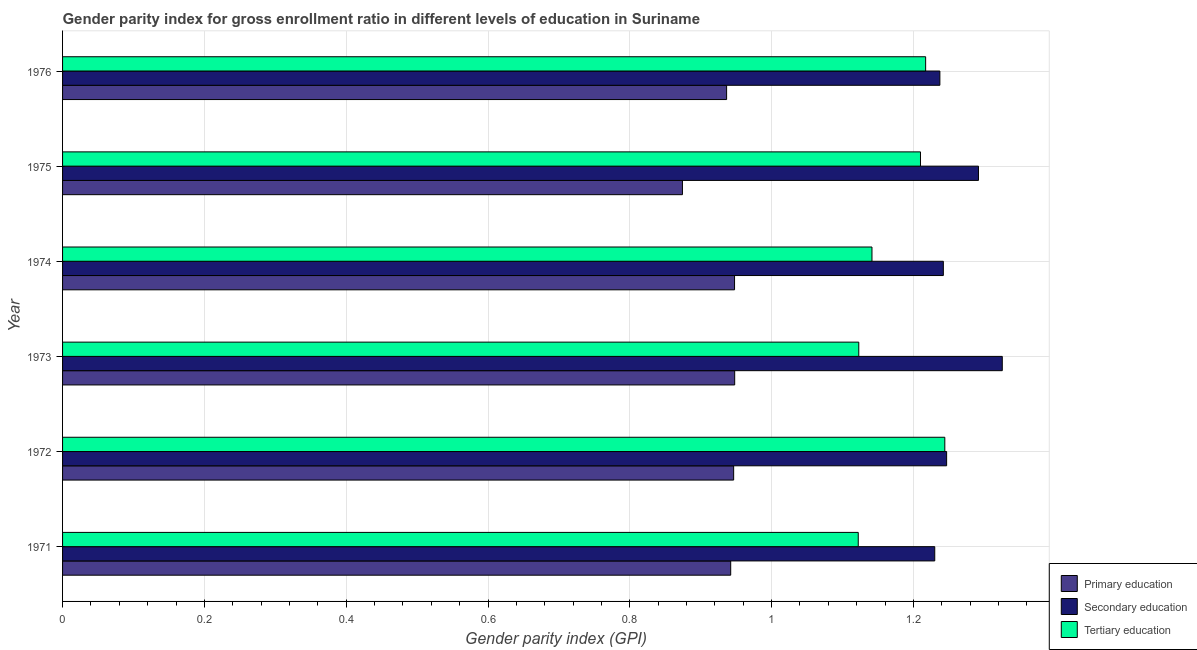How many different coloured bars are there?
Provide a short and direct response. 3. How many groups of bars are there?
Keep it short and to the point. 6. How many bars are there on the 5th tick from the top?
Your answer should be very brief. 3. In how many cases, is the number of bars for a given year not equal to the number of legend labels?
Make the answer very short. 0. What is the gender parity index in primary education in 1971?
Provide a succinct answer. 0.94. Across all years, what is the maximum gender parity index in secondary education?
Your answer should be very brief. 1.33. Across all years, what is the minimum gender parity index in primary education?
Provide a short and direct response. 0.87. In which year was the gender parity index in tertiary education maximum?
Ensure brevity in your answer.  1972. What is the total gender parity index in primary education in the graph?
Make the answer very short. 5.6. What is the difference between the gender parity index in secondary education in 1975 and that in 1976?
Your answer should be compact. 0.05. What is the difference between the gender parity index in secondary education in 1973 and the gender parity index in primary education in 1972?
Keep it short and to the point. 0.38. What is the average gender parity index in primary education per year?
Keep it short and to the point. 0.93. In the year 1976, what is the difference between the gender parity index in secondary education and gender parity index in tertiary education?
Your response must be concise. 0.02. What is the ratio of the gender parity index in primary education in 1973 to that in 1975?
Offer a terse response. 1.08. What is the difference between the highest and the lowest gender parity index in primary education?
Offer a very short reply. 0.07. In how many years, is the gender parity index in primary education greater than the average gender parity index in primary education taken over all years?
Provide a succinct answer. 5. Is the sum of the gender parity index in primary education in 1971 and 1972 greater than the maximum gender parity index in secondary education across all years?
Keep it short and to the point. Yes. What does the 2nd bar from the top in 1974 represents?
Provide a short and direct response. Secondary education. What does the 3rd bar from the bottom in 1975 represents?
Make the answer very short. Tertiary education. Is it the case that in every year, the sum of the gender parity index in primary education and gender parity index in secondary education is greater than the gender parity index in tertiary education?
Ensure brevity in your answer.  Yes. How many bars are there?
Give a very brief answer. 18. Are all the bars in the graph horizontal?
Ensure brevity in your answer.  Yes. How many years are there in the graph?
Keep it short and to the point. 6. What is the difference between two consecutive major ticks on the X-axis?
Your response must be concise. 0.2. Does the graph contain any zero values?
Your answer should be compact. No. How many legend labels are there?
Make the answer very short. 3. What is the title of the graph?
Provide a succinct answer. Gender parity index for gross enrollment ratio in different levels of education in Suriname. What is the label or title of the X-axis?
Give a very brief answer. Gender parity index (GPI). What is the Gender parity index (GPI) in Primary education in 1971?
Keep it short and to the point. 0.94. What is the Gender parity index (GPI) of Secondary education in 1971?
Give a very brief answer. 1.23. What is the Gender parity index (GPI) in Tertiary education in 1971?
Ensure brevity in your answer.  1.12. What is the Gender parity index (GPI) of Primary education in 1972?
Provide a succinct answer. 0.95. What is the Gender parity index (GPI) of Secondary education in 1972?
Your answer should be compact. 1.25. What is the Gender parity index (GPI) in Tertiary education in 1972?
Ensure brevity in your answer.  1.24. What is the Gender parity index (GPI) of Primary education in 1973?
Give a very brief answer. 0.95. What is the Gender parity index (GPI) in Secondary education in 1973?
Give a very brief answer. 1.33. What is the Gender parity index (GPI) in Tertiary education in 1973?
Offer a terse response. 1.12. What is the Gender parity index (GPI) of Primary education in 1974?
Offer a terse response. 0.95. What is the Gender parity index (GPI) of Secondary education in 1974?
Provide a succinct answer. 1.24. What is the Gender parity index (GPI) in Tertiary education in 1974?
Make the answer very short. 1.14. What is the Gender parity index (GPI) of Primary education in 1975?
Provide a short and direct response. 0.87. What is the Gender parity index (GPI) of Secondary education in 1975?
Your answer should be compact. 1.29. What is the Gender parity index (GPI) of Tertiary education in 1975?
Your response must be concise. 1.21. What is the Gender parity index (GPI) of Primary education in 1976?
Provide a succinct answer. 0.94. What is the Gender parity index (GPI) in Secondary education in 1976?
Offer a very short reply. 1.24. What is the Gender parity index (GPI) of Tertiary education in 1976?
Make the answer very short. 1.22. Across all years, what is the maximum Gender parity index (GPI) of Primary education?
Your response must be concise. 0.95. Across all years, what is the maximum Gender parity index (GPI) in Secondary education?
Your answer should be very brief. 1.33. Across all years, what is the maximum Gender parity index (GPI) of Tertiary education?
Offer a terse response. 1.24. Across all years, what is the minimum Gender parity index (GPI) of Primary education?
Provide a succinct answer. 0.87. Across all years, what is the minimum Gender parity index (GPI) in Secondary education?
Offer a terse response. 1.23. Across all years, what is the minimum Gender parity index (GPI) in Tertiary education?
Provide a succinct answer. 1.12. What is the total Gender parity index (GPI) in Primary education in the graph?
Offer a very short reply. 5.6. What is the total Gender parity index (GPI) of Secondary education in the graph?
Make the answer very short. 7.57. What is the total Gender parity index (GPI) of Tertiary education in the graph?
Provide a succinct answer. 7.06. What is the difference between the Gender parity index (GPI) of Primary education in 1971 and that in 1972?
Your answer should be compact. -0. What is the difference between the Gender parity index (GPI) of Secondary education in 1971 and that in 1972?
Your answer should be very brief. -0.02. What is the difference between the Gender parity index (GPI) of Tertiary education in 1971 and that in 1972?
Give a very brief answer. -0.12. What is the difference between the Gender parity index (GPI) in Primary education in 1971 and that in 1973?
Provide a short and direct response. -0.01. What is the difference between the Gender parity index (GPI) in Secondary education in 1971 and that in 1973?
Offer a very short reply. -0.1. What is the difference between the Gender parity index (GPI) in Tertiary education in 1971 and that in 1973?
Your response must be concise. -0. What is the difference between the Gender parity index (GPI) in Primary education in 1971 and that in 1974?
Your answer should be very brief. -0.01. What is the difference between the Gender parity index (GPI) of Secondary education in 1971 and that in 1974?
Provide a short and direct response. -0.01. What is the difference between the Gender parity index (GPI) of Tertiary education in 1971 and that in 1974?
Provide a succinct answer. -0.02. What is the difference between the Gender parity index (GPI) in Primary education in 1971 and that in 1975?
Your answer should be compact. 0.07. What is the difference between the Gender parity index (GPI) in Secondary education in 1971 and that in 1975?
Ensure brevity in your answer.  -0.06. What is the difference between the Gender parity index (GPI) of Tertiary education in 1971 and that in 1975?
Ensure brevity in your answer.  -0.09. What is the difference between the Gender parity index (GPI) in Primary education in 1971 and that in 1976?
Make the answer very short. 0.01. What is the difference between the Gender parity index (GPI) in Secondary education in 1971 and that in 1976?
Your answer should be compact. -0.01. What is the difference between the Gender parity index (GPI) of Tertiary education in 1971 and that in 1976?
Your answer should be very brief. -0.1. What is the difference between the Gender parity index (GPI) in Primary education in 1972 and that in 1973?
Your answer should be compact. -0. What is the difference between the Gender parity index (GPI) of Secondary education in 1972 and that in 1973?
Your response must be concise. -0.08. What is the difference between the Gender parity index (GPI) of Tertiary education in 1972 and that in 1973?
Your answer should be compact. 0.12. What is the difference between the Gender parity index (GPI) in Primary education in 1972 and that in 1974?
Your response must be concise. -0. What is the difference between the Gender parity index (GPI) in Secondary education in 1972 and that in 1974?
Keep it short and to the point. 0. What is the difference between the Gender parity index (GPI) in Tertiary education in 1972 and that in 1974?
Provide a short and direct response. 0.1. What is the difference between the Gender parity index (GPI) in Primary education in 1972 and that in 1975?
Keep it short and to the point. 0.07. What is the difference between the Gender parity index (GPI) in Secondary education in 1972 and that in 1975?
Your answer should be compact. -0.04. What is the difference between the Gender parity index (GPI) of Tertiary education in 1972 and that in 1975?
Your answer should be very brief. 0.03. What is the difference between the Gender parity index (GPI) of Primary education in 1972 and that in 1976?
Provide a succinct answer. 0.01. What is the difference between the Gender parity index (GPI) of Secondary education in 1972 and that in 1976?
Your answer should be very brief. 0.01. What is the difference between the Gender parity index (GPI) of Tertiary education in 1972 and that in 1976?
Provide a succinct answer. 0.03. What is the difference between the Gender parity index (GPI) of Primary education in 1973 and that in 1974?
Your answer should be very brief. 0. What is the difference between the Gender parity index (GPI) in Secondary education in 1973 and that in 1974?
Offer a terse response. 0.08. What is the difference between the Gender parity index (GPI) of Tertiary education in 1973 and that in 1974?
Offer a terse response. -0.02. What is the difference between the Gender parity index (GPI) in Primary education in 1973 and that in 1975?
Make the answer very short. 0.07. What is the difference between the Gender parity index (GPI) of Secondary education in 1973 and that in 1975?
Provide a succinct answer. 0.03. What is the difference between the Gender parity index (GPI) in Tertiary education in 1973 and that in 1975?
Provide a succinct answer. -0.09. What is the difference between the Gender parity index (GPI) in Primary education in 1973 and that in 1976?
Offer a very short reply. 0.01. What is the difference between the Gender parity index (GPI) in Secondary education in 1973 and that in 1976?
Offer a terse response. 0.09. What is the difference between the Gender parity index (GPI) of Tertiary education in 1973 and that in 1976?
Ensure brevity in your answer.  -0.09. What is the difference between the Gender parity index (GPI) in Primary education in 1974 and that in 1975?
Your response must be concise. 0.07. What is the difference between the Gender parity index (GPI) of Secondary education in 1974 and that in 1975?
Your answer should be very brief. -0.05. What is the difference between the Gender parity index (GPI) in Tertiary education in 1974 and that in 1975?
Ensure brevity in your answer.  -0.07. What is the difference between the Gender parity index (GPI) in Primary education in 1974 and that in 1976?
Ensure brevity in your answer.  0.01. What is the difference between the Gender parity index (GPI) in Secondary education in 1974 and that in 1976?
Your answer should be compact. 0. What is the difference between the Gender parity index (GPI) in Tertiary education in 1974 and that in 1976?
Make the answer very short. -0.08. What is the difference between the Gender parity index (GPI) of Primary education in 1975 and that in 1976?
Your response must be concise. -0.06. What is the difference between the Gender parity index (GPI) in Secondary education in 1975 and that in 1976?
Offer a very short reply. 0.05. What is the difference between the Gender parity index (GPI) of Tertiary education in 1975 and that in 1976?
Offer a very short reply. -0.01. What is the difference between the Gender parity index (GPI) in Primary education in 1971 and the Gender parity index (GPI) in Secondary education in 1972?
Your response must be concise. -0.3. What is the difference between the Gender parity index (GPI) in Primary education in 1971 and the Gender parity index (GPI) in Tertiary education in 1972?
Make the answer very short. -0.3. What is the difference between the Gender parity index (GPI) in Secondary education in 1971 and the Gender parity index (GPI) in Tertiary education in 1972?
Your answer should be compact. -0.01. What is the difference between the Gender parity index (GPI) in Primary education in 1971 and the Gender parity index (GPI) in Secondary education in 1973?
Offer a terse response. -0.38. What is the difference between the Gender parity index (GPI) of Primary education in 1971 and the Gender parity index (GPI) of Tertiary education in 1973?
Your answer should be compact. -0.18. What is the difference between the Gender parity index (GPI) of Secondary education in 1971 and the Gender parity index (GPI) of Tertiary education in 1973?
Make the answer very short. 0.11. What is the difference between the Gender parity index (GPI) of Primary education in 1971 and the Gender parity index (GPI) of Secondary education in 1974?
Provide a short and direct response. -0.3. What is the difference between the Gender parity index (GPI) of Primary education in 1971 and the Gender parity index (GPI) of Tertiary education in 1974?
Your answer should be compact. -0.2. What is the difference between the Gender parity index (GPI) of Secondary education in 1971 and the Gender parity index (GPI) of Tertiary education in 1974?
Ensure brevity in your answer.  0.09. What is the difference between the Gender parity index (GPI) of Primary education in 1971 and the Gender parity index (GPI) of Secondary education in 1975?
Provide a short and direct response. -0.35. What is the difference between the Gender parity index (GPI) in Primary education in 1971 and the Gender parity index (GPI) in Tertiary education in 1975?
Keep it short and to the point. -0.27. What is the difference between the Gender parity index (GPI) of Secondary education in 1971 and the Gender parity index (GPI) of Tertiary education in 1975?
Your answer should be compact. 0.02. What is the difference between the Gender parity index (GPI) of Primary education in 1971 and the Gender parity index (GPI) of Secondary education in 1976?
Your answer should be compact. -0.29. What is the difference between the Gender parity index (GPI) in Primary education in 1971 and the Gender parity index (GPI) in Tertiary education in 1976?
Provide a short and direct response. -0.27. What is the difference between the Gender parity index (GPI) of Secondary education in 1971 and the Gender parity index (GPI) of Tertiary education in 1976?
Keep it short and to the point. 0.01. What is the difference between the Gender parity index (GPI) in Primary education in 1972 and the Gender parity index (GPI) in Secondary education in 1973?
Your response must be concise. -0.38. What is the difference between the Gender parity index (GPI) in Primary education in 1972 and the Gender parity index (GPI) in Tertiary education in 1973?
Provide a short and direct response. -0.18. What is the difference between the Gender parity index (GPI) of Secondary education in 1972 and the Gender parity index (GPI) of Tertiary education in 1973?
Offer a terse response. 0.12. What is the difference between the Gender parity index (GPI) of Primary education in 1972 and the Gender parity index (GPI) of Secondary education in 1974?
Give a very brief answer. -0.3. What is the difference between the Gender parity index (GPI) of Primary education in 1972 and the Gender parity index (GPI) of Tertiary education in 1974?
Your answer should be compact. -0.2. What is the difference between the Gender parity index (GPI) in Secondary education in 1972 and the Gender parity index (GPI) in Tertiary education in 1974?
Offer a very short reply. 0.11. What is the difference between the Gender parity index (GPI) in Primary education in 1972 and the Gender parity index (GPI) in Secondary education in 1975?
Offer a terse response. -0.35. What is the difference between the Gender parity index (GPI) of Primary education in 1972 and the Gender parity index (GPI) of Tertiary education in 1975?
Give a very brief answer. -0.26. What is the difference between the Gender parity index (GPI) in Secondary education in 1972 and the Gender parity index (GPI) in Tertiary education in 1975?
Offer a terse response. 0.04. What is the difference between the Gender parity index (GPI) in Primary education in 1972 and the Gender parity index (GPI) in Secondary education in 1976?
Your response must be concise. -0.29. What is the difference between the Gender parity index (GPI) of Primary education in 1972 and the Gender parity index (GPI) of Tertiary education in 1976?
Provide a succinct answer. -0.27. What is the difference between the Gender parity index (GPI) in Secondary education in 1972 and the Gender parity index (GPI) in Tertiary education in 1976?
Make the answer very short. 0.03. What is the difference between the Gender parity index (GPI) of Primary education in 1973 and the Gender parity index (GPI) of Secondary education in 1974?
Provide a short and direct response. -0.29. What is the difference between the Gender parity index (GPI) in Primary education in 1973 and the Gender parity index (GPI) in Tertiary education in 1974?
Offer a terse response. -0.19. What is the difference between the Gender parity index (GPI) of Secondary education in 1973 and the Gender parity index (GPI) of Tertiary education in 1974?
Make the answer very short. 0.18. What is the difference between the Gender parity index (GPI) in Primary education in 1973 and the Gender parity index (GPI) in Secondary education in 1975?
Provide a short and direct response. -0.34. What is the difference between the Gender parity index (GPI) of Primary education in 1973 and the Gender parity index (GPI) of Tertiary education in 1975?
Give a very brief answer. -0.26. What is the difference between the Gender parity index (GPI) in Secondary education in 1973 and the Gender parity index (GPI) in Tertiary education in 1975?
Provide a succinct answer. 0.12. What is the difference between the Gender parity index (GPI) in Primary education in 1973 and the Gender parity index (GPI) in Secondary education in 1976?
Your response must be concise. -0.29. What is the difference between the Gender parity index (GPI) in Primary education in 1973 and the Gender parity index (GPI) in Tertiary education in 1976?
Give a very brief answer. -0.27. What is the difference between the Gender parity index (GPI) of Secondary education in 1973 and the Gender parity index (GPI) of Tertiary education in 1976?
Offer a terse response. 0.11. What is the difference between the Gender parity index (GPI) in Primary education in 1974 and the Gender parity index (GPI) in Secondary education in 1975?
Provide a succinct answer. -0.34. What is the difference between the Gender parity index (GPI) of Primary education in 1974 and the Gender parity index (GPI) of Tertiary education in 1975?
Offer a terse response. -0.26. What is the difference between the Gender parity index (GPI) in Secondary education in 1974 and the Gender parity index (GPI) in Tertiary education in 1975?
Ensure brevity in your answer.  0.03. What is the difference between the Gender parity index (GPI) of Primary education in 1974 and the Gender parity index (GPI) of Secondary education in 1976?
Offer a terse response. -0.29. What is the difference between the Gender parity index (GPI) of Primary education in 1974 and the Gender parity index (GPI) of Tertiary education in 1976?
Your response must be concise. -0.27. What is the difference between the Gender parity index (GPI) of Secondary education in 1974 and the Gender parity index (GPI) of Tertiary education in 1976?
Provide a succinct answer. 0.03. What is the difference between the Gender parity index (GPI) in Primary education in 1975 and the Gender parity index (GPI) in Secondary education in 1976?
Provide a succinct answer. -0.36. What is the difference between the Gender parity index (GPI) in Primary education in 1975 and the Gender parity index (GPI) in Tertiary education in 1976?
Your response must be concise. -0.34. What is the difference between the Gender parity index (GPI) of Secondary education in 1975 and the Gender parity index (GPI) of Tertiary education in 1976?
Provide a succinct answer. 0.07. What is the average Gender parity index (GPI) of Primary education per year?
Give a very brief answer. 0.93. What is the average Gender parity index (GPI) in Secondary education per year?
Ensure brevity in your answer.  1.26. What is the average Gender parity index (GPI) in Tertiary education per year?
Your response must be concise. 1.18. In the year 1971, what is the difference between the Gender parity index (GPI) of Primary education and Gender parity index (GPI) of Secondary education?
Give a very brief answer. -0.29. In the year 1971, what is the difference between the Gender parity index (GPI) in Primary education and Gender parity index (GPI) in Tertiary education?
Give a very brief answer. -0.18. In the year 1971, what is the difference between the Gender parity index (GPI) in Secondary education and Gender parity index (GPI) in Tertiary education?
Your answer should be very brief. 0.11. In the year 1972, what is the difference between the Gender parity index (GPI) in Primary education and Gender parity index (GPI) in Secondary education?
Offer a very short reply. -0.3. In the year 1972, what is the difference between the Gender parity index (GPI) of Primary education and Gender parity index (GPI) of Tertiary education?
Your response must be concise. -0.3. In the year 1972, what is the difference between the Gender parity index (GPI) of Secondary education and Gender parity index (GPI) of Tertiary education?
Keep it short and to the point. 0. In the year 1973, what is the difference between the Gender parity index (GPI) in Primary education and Gender parity index (GPI) in Secondary education?
Offer a very short reply. -0.38. In the year 1973, what is the difference between the Gender parity index (GPI) of Primary education and Gender parity index (GPI) of Tertiary education?
Ensure brevity in your answer.  -0.17. In the year 1973, what is the difference between the Gender parity index (GPI) of Secondary education and Gender parity index (GPI) of Tertiary education?
Provide a short and direct response. 0.2. In the year 1974, what is the difference between the Gender parity index (GPI) of Primary education and Gender parity index (GPI) of Secondary education?
Your answer should be very brief. -0.29. In the year 1974, what is the difference between the Gender parity index (GPI) of Primary education and Gender parity index (GPI) of Tertiary education?
Give a very brief answer. -0.19. In the year 1974, what is the difference between the Gender parity index (GPI) of Secondary education and Gender parity index (GPI) of Tertiary education?
Your answer should be very brief. 0.1. In the year 1975, what is the difference between the Gender parity index (GPI) of Primary education and Gender parity index (GPI) of Secondary education?
Provide a short and direct response. -0.42. In the year 1975, what is the difference between the Gender parity index (GPI) in Primary education and Gender parity index (GPI) in Tertiary education?
Your answer should be very brief. -0.34. In the year 1975, what is the difference between the Gender parity index (GPI) of Secondary education and Gender parity index (GPI) of Tertiary education?
Your answer should be compact. 0.08. In the year 1976, what is the difference between the Gender parity index (GPI) of Primary education and Gender parity index (GPI) of Secondary education?
Keep it short and to the point. -0.3. In the year 1976, what is the difference between the Gender parity index (GPI) in Primary education and Gender parity index (GPI) in Tertiary education?
Make the answer very short. -0.28. In the year 1976, what is the difference between the Gender parity index (GPI) in Secondary education and Gender parity index (GPI) in Tertiary education?
Your response must be concise. 0.02. What is the ratio of the Gender parity index (GPI) of Secondary education in 1971 to that in 1972?
Provide a succinct answer. 0.99. What is the ratio of the Gender parity index (GPI) in Tertiary education in 1971 to that in 1972?
Offer a very short reply. 0.9. What is the ratio of the Gender parity index (GPI) in Primary education in 1971 to that in 1973?
Your response must be concise. 0.99. What is the ratio of the Gender parity index (GPI) in Secondary education in 1971 to that in 1973?
Give a very brief answer. 0.93. What is the ratio of the Gender parity index (GPI) in Primary education in 1971 to that in 1974?
Provide a succinct answer. 0.99. What is the ratio of the Gender parity index (GPI) in Secondary education in 1971 to that in 1974?
Your response must be concise. 0.99. What is the ratio of the Gender parity index (GPI) in Tertiary education in 1971 to that in 1974?
Provide a short and direct response. 0.98. What is the ratio of the Gender parity index (GPI) in Primary education in 1971 to that in 1975?
Give a very brief answer. 1.08. What is the ratio of the Gender parity index (GPI) of Secondary education in 1971 to that in 1975?
Give a very brief answer. 0.95. What is the ratio of the Gender parity index (GPI) in Tertiary education in 1971 to that in 1975?
Your answer should be very brief. 0.93. What is the ratio of the Gender parity index (GPI) in Secondary education in 1971 to that in 1976?
Ensure brevity in your answer.  0.99. What is the ratio of the Gender parity index (GPI) of Tertiary education in 1971 to that in 1976?
Ensure brevity in your answer.  0.92. What is the ratio of the Gender parity index (GPI) in Secondary education in 1972 to that in 1973?
Your answer should be compact. 0.94. What is the ratio of the Gender parity index (GPI) in Tertiary education in 1972 to that in 1973?
Make the answer very short. 1.11. What is the ratio of the Gender parity index (GPI) of Primary education in 1972 to that in 1974?
Your answer should be very brief. 1. What is the ratio of the Gender parity index (GPI) in Secondary education in 1972 to that in 1974?
Provide a short and direct response. 1. What is the ratio of the Gender parity index (GPI) in Tertiary education in 1972 to that in 1974?
Provide a short and direct response. 1.09. What is the ratio of the Gender parity index (GPI) of Primary education in 1972 to that in 1975?
Your answer should be very brief. 1.08. What is the ratio of the Gender parity index (GPI) of Secondary education in 1972 to that in 1975?
Make the answer very short. 0.97. What is the ratio of the Gender parity index (GPI) of Tertiary education in 1972 to that in 1975?
Ensure brevity in your answer.  1.03. What is the ratio of the Gender parity index (GPI) in Primary education in 1972 to that in 1976?
Your answer should be very brief. 1.01. What is the ratio of the Gender parity index (GPI) in Secondary education in 1972 to that in 1976?
Offer a very short reply. 1.01. What is the ratio of the Gender parity index (GPI) in Tertiary education in 1972 to that in 1976?
Make the answer very short. 1.02. What is the ratio of the Gender parity index (GPI) of Primary education in 1973 to that in 1974?
Offer a very short reply. 1. What is the ratio of the Gender parity index (GPI) of Secondary education in 1973 to that in 1974?
Give a very brief answer. 1.07. What is the ratio of the Gender parity index (GPI) in Tertiary education in 1973 to that in 1974?
Offer a very short reply. 0.98. What is the ratio of the Gender parity index (GPI) of Primary education in 1973 to that in 1975?
Ensure brevity in your answer.  1.08. What is the ratio of the Gender parity index (GPI) in Tertiary education in 1973 to that in 1975?
Offer a terse response. 0.93. What is the ratio of the Gender parity index (GPI) of Primary education in 1973 to that in 1976?
Provide a succinct answer. 1.01. What is the ratio of the Gender parity index (GPI) of Secondary education in 1973 to that in 1976?
Offer a terse response. 1.07. What is the ratio of the Gender parity index (GPI) in Tertiary education in 1973 to that in 1976?
Offer a very short reply. 0.92. What is the ratio of the Gender parity index (GPI) of Primary education in 1974 to that in 1975?
Provide a short and direct response. 1.08. What is the ratio of the Gender parity index (GPI) of Secondary education in 1974 to that in 1975?
Offer a terse response. 0.96. What is the ratio of the Gender parity index (GPI) in Tertiary education in 1974 to that in 1975?
Offer a very short reply. 0.94. What is the ratio of the Gender parity index (GPI) of Primary education in 1974 to that in 1976?
Keep it short and to the point. 1.01. What is the ratio of the Gender parity index (GPI) in Tertiary education in 1974 to that in 1976?
Give a very brief answer. 0.94. What is the ratio of the Gender parity index (GPI) of Primary education in 1975 to that in 1976?
Provide a succinct answer. 0.93. What is the ratio of the Gender parity index (GPI) of Secondary education in 1975 to that in 1976?
Make the answer very short. 1.04. What is the difference between the highest and the second highest Gender parity index (GPI) of Primary education?
Your answer should be compact. 0. What is the difference between the highest and the second highest Gender parity index (GPI) in Secondary education?
Your answer should be very brief. 0.03. What is the difference between the highest and the second highest Gender parity index (GPI) in Tertiary education?
Your response must be concise. 0.03. What is the difference between the highest and the lowest Gender parity index (GPI) in Primary education?
Your answer should be compact. 0.07. What is the difference between the highest and the lowest Gender parity index (GPI) of Secondary education?
Provide a short and direct response. 0.1. What is the difference between the highest and the lowest Gender parity index (GPI) of Tertiary education?
Provide a short and direct response. 0.12. 